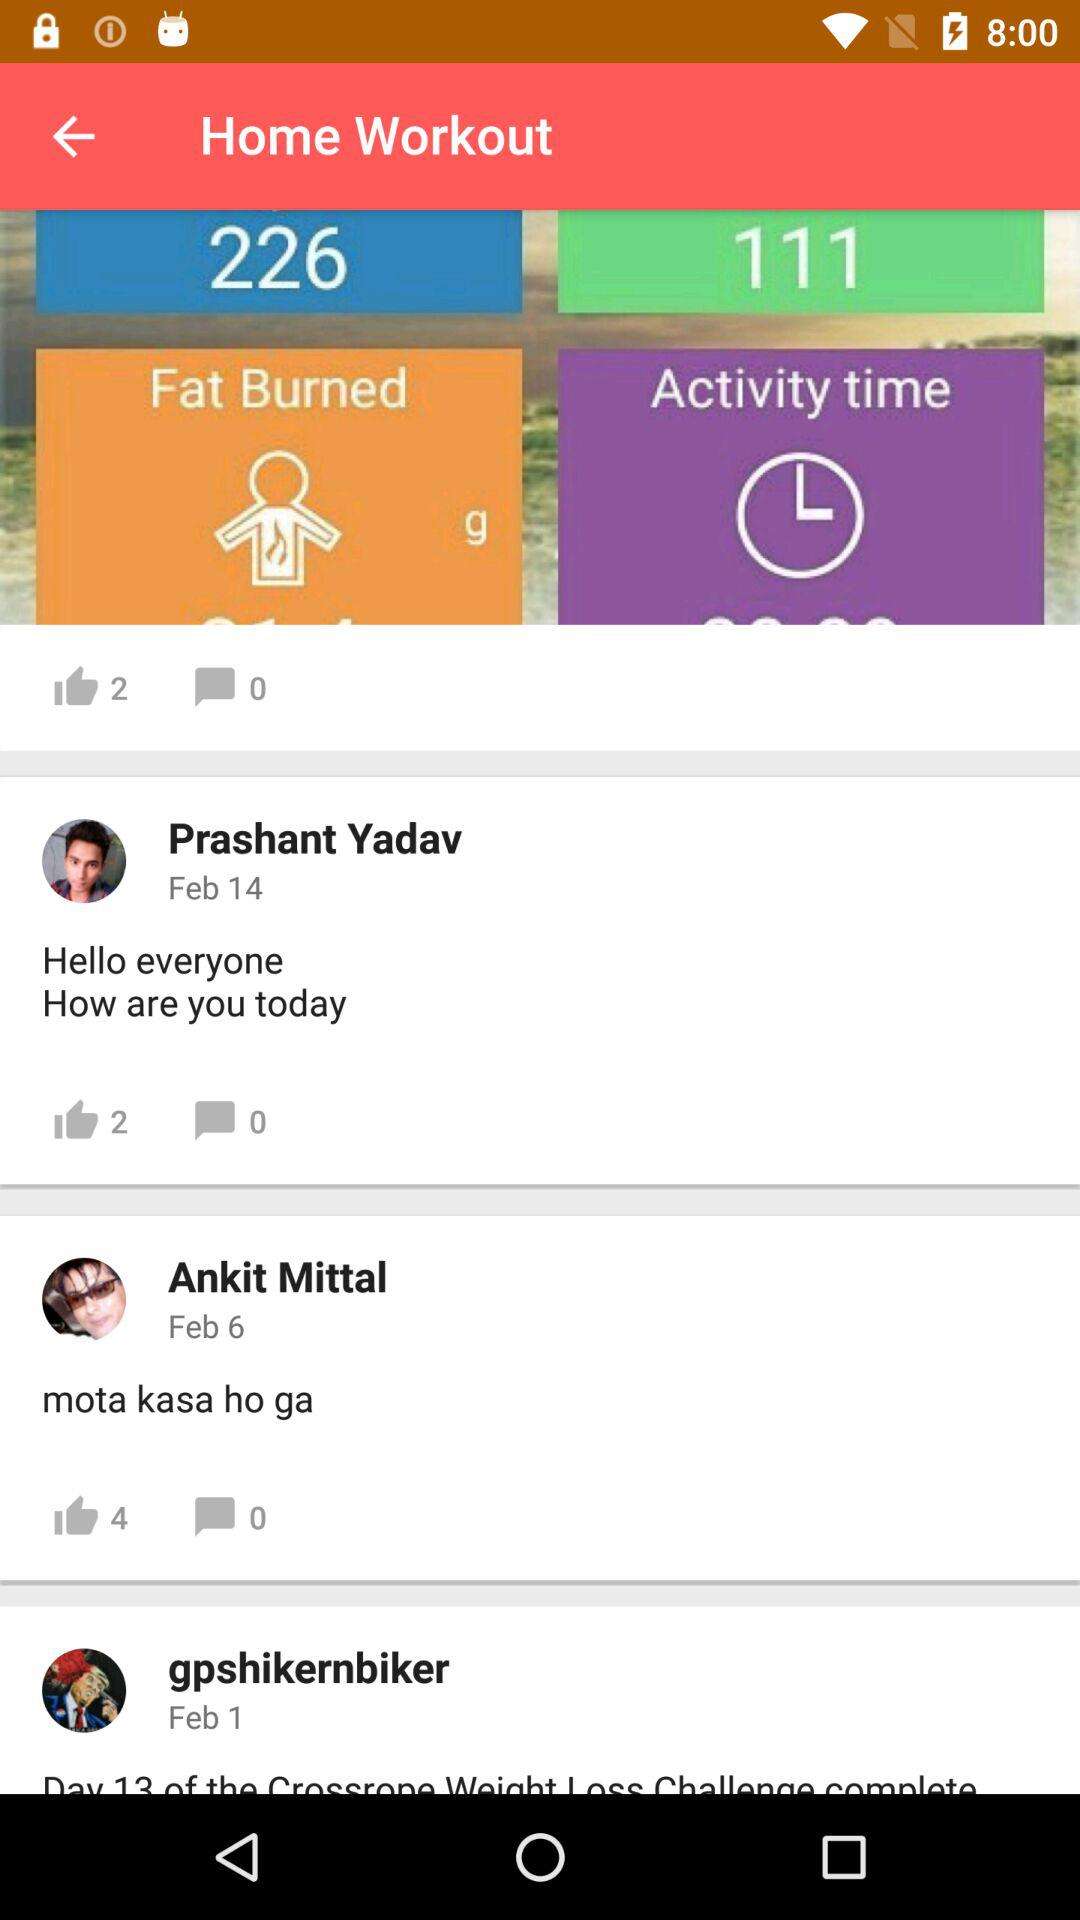What is the application name? The name of the application is "Home Workout". 